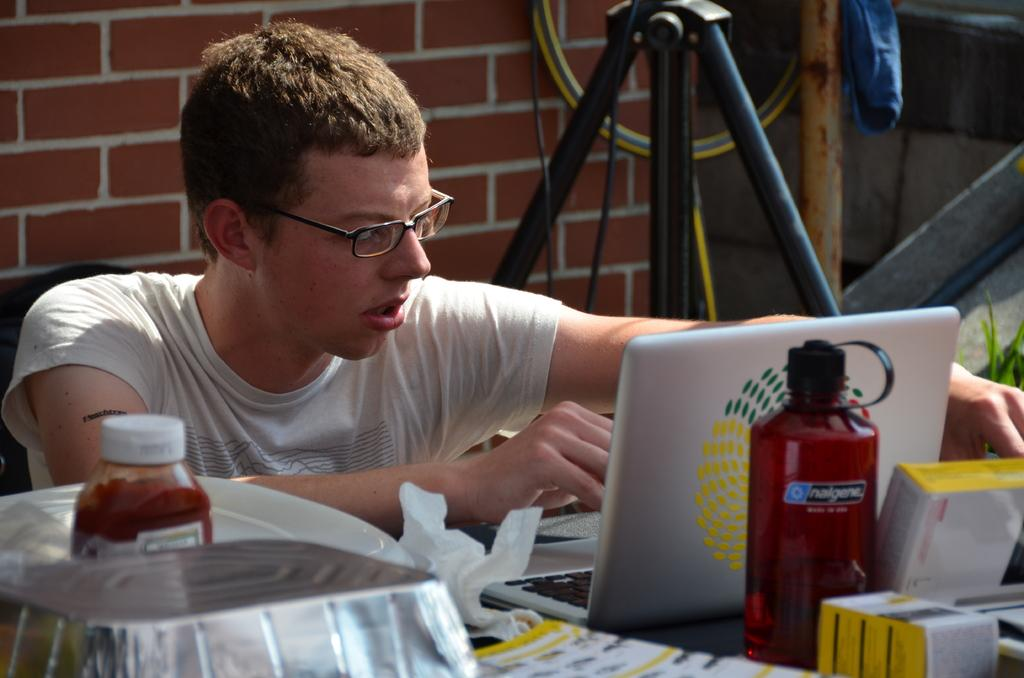What is the main subject of the image? The main subject of the image is a man. Can you describe the man's position in the image? The man is sitting at a table. What activity is the man engaged in? The man is working on his laptop. Can you hear the crow laughing in the image? There is no crow or laughter present in the image; it only features a man sitting at a table and working on his laptop. 